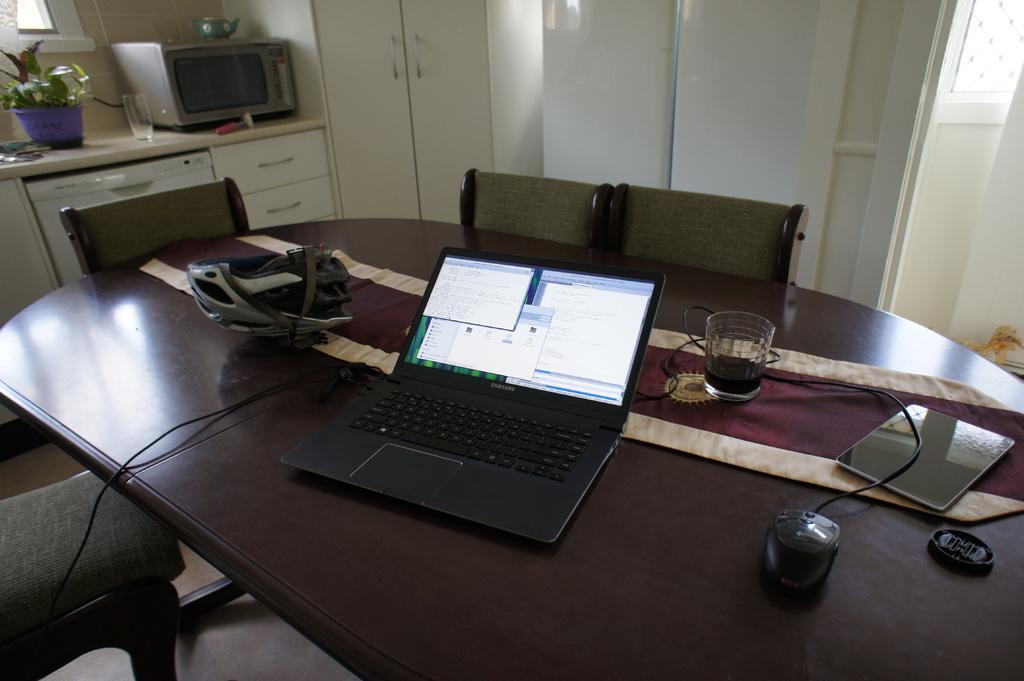Could you give a brief overview of what you see in this image? The table contains a laptop,mouse, a glass with a drink in it,tab,helmet and a group of chairs around it there is also a micro oven in the left corner. 